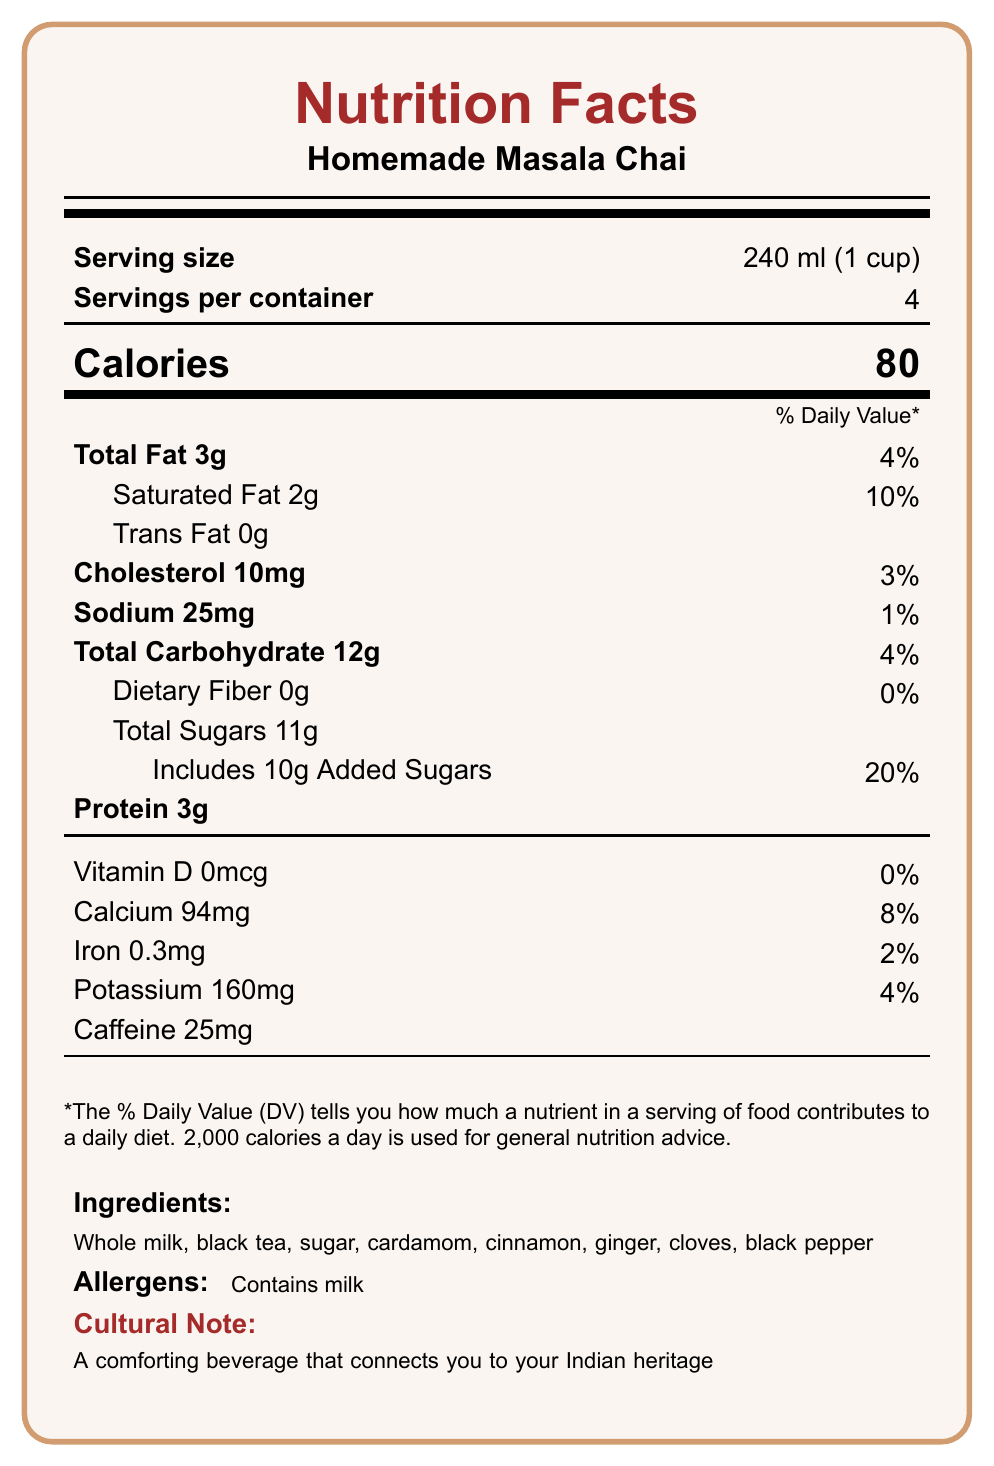what is the serving size for Homemade Masala Chai? The document clearly states the serving size next to the label "Serving size".
Answer: 240 ml (1 cup) what is the caffeine content in Homemade Masala Chai? The document lists the caffeine content under the nutrition information section next to the label "Caffeine".
Answer: 25mg how many calories are in one serving of Homemade Masala Chai? The number of calories is prominently displayed in the middle of the document under the label "Calories".
Answer: 80 what is the daily value percentage of added sugars in one serving? The document shows the daily value percentage of added sugars next to the label "Includes 10g Added Sugars".
Answer: 20% where does the beverage contain allergens? The document specifies in the allergens section stating "Contains milk".
Answer: Contains milk how much calcium is in one serving? A. 94mg B. 160mg C. 25mg D. 10mg The calcium content is listed as 94mg under the nutrition information.
Answer: A which of the following has the highest caffeine content? A. Homemade Masala Chai B. Starbucks Coffee (Grande) C. Red Bull Energy Drink (8.4 fl oz) D. Coca-Cola Classic (12 fl oz) Starbucks Coffee (Grande) has 310mg of caffeine, which is the highest among the listed beverages.
Answer: B is there any dietary fiber in Homemade Masala Chai? The document states that the dietary fiber content is 0g.
Answer: No describe the main idea of the document. The document presents comprehensive nutritional information along with cultural context, aiming to inform and connect the reader to the heritage associated with Masala Chai.
Answer: The main idea of the document is to provide the nutrition facts and cultural significance of Homemade Masala Chai, which includes serving size, calorie content, detailed nutrient breakdown, ingredients, allergens, and caffeine content compared to popular Western beverages. It aims to highlight the beverage's traditional Indian roots and potential health benefits. what black tea brand is used in Homemade Masala Chai? The document only mentions "black tea" as one of the ingredients but does not specify the brand.
Answer: Not enough information how can you support sustainable farming practices when making Masala Chai? The document includes a sustainability note indicating ways to support sustainable farming practices.
Answer: Try using organic, fair-trade tea and locally sourced spices. 